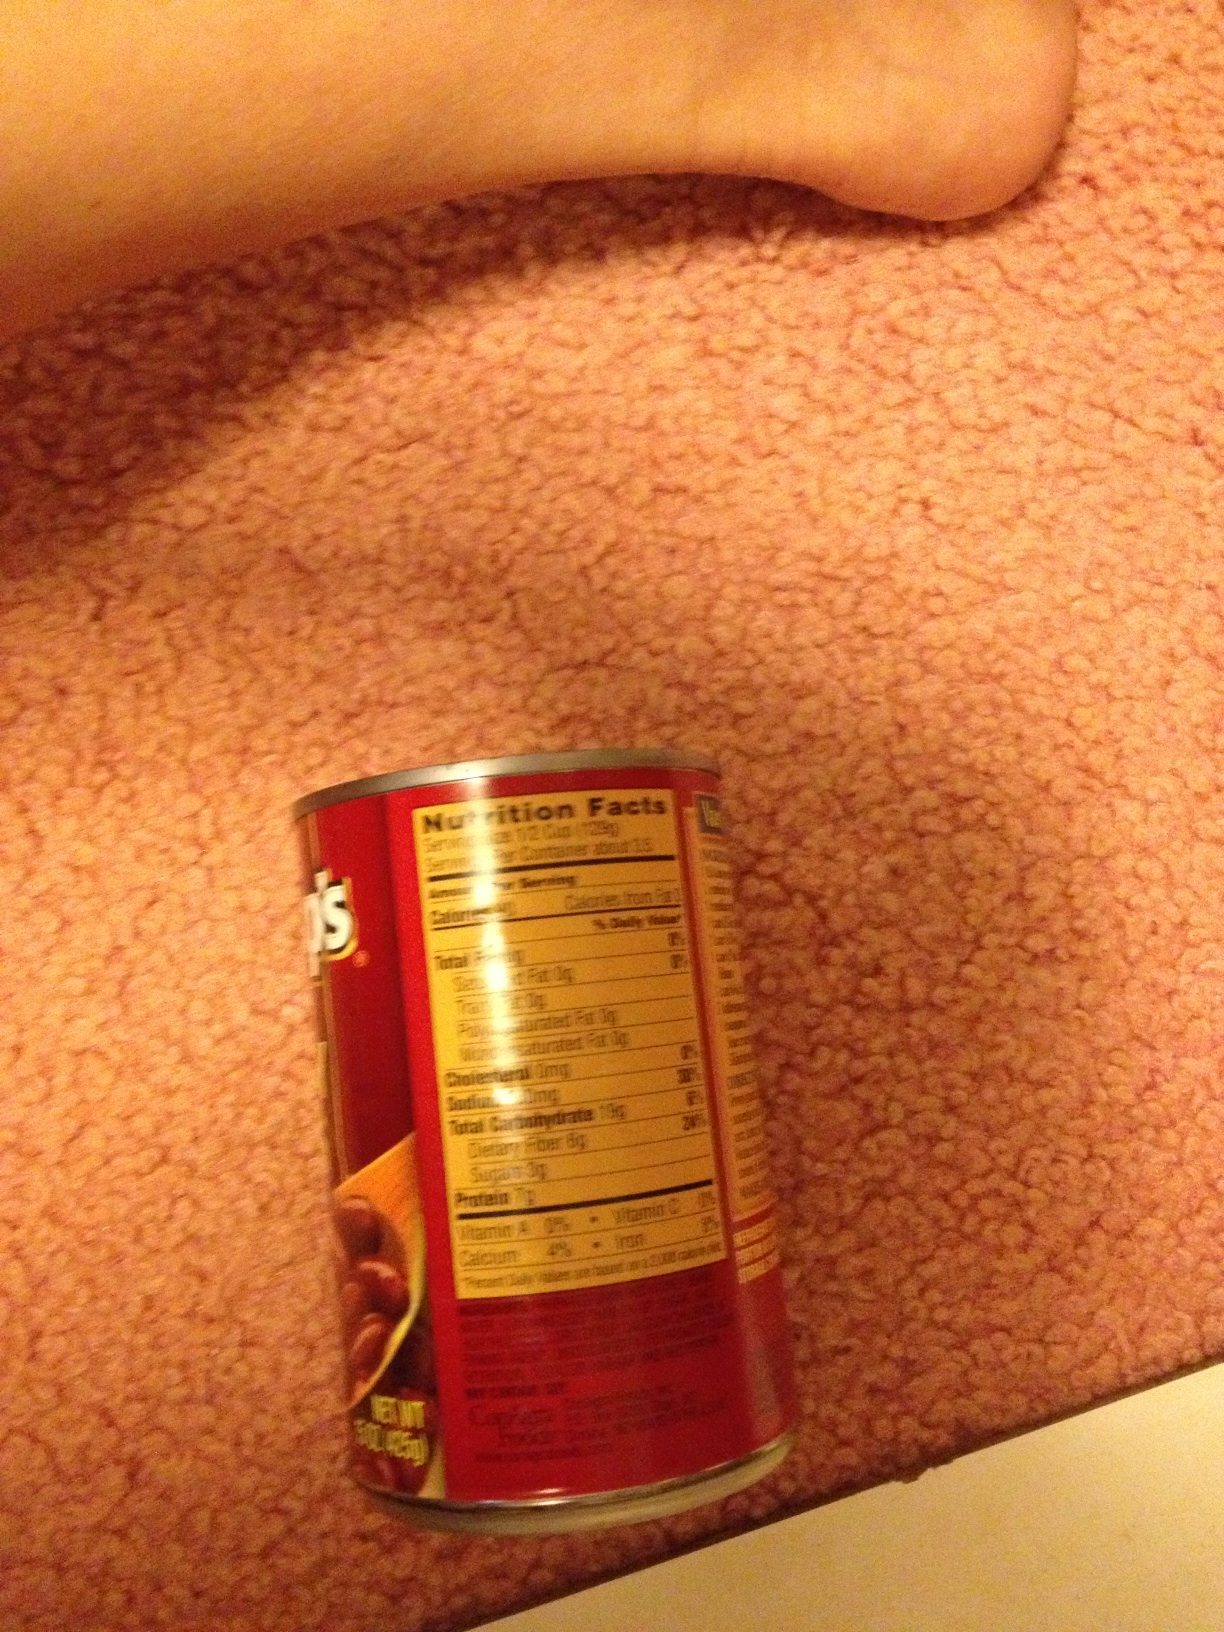Imagine this can is a time traveler. Where has it been, and what has it seen? This can of beans, a seasoned time traveler, has witnessed eras of culinary history. It journeyed through the ancient kitchens of Rome, where beans were a staple protein source. It traveled to medieval Europe, seeing how beans were cultivated and consumed by villagers. In the 1800s, it was introduced to the Americas, adapting to various recipes from Latin America to the Deep South. It even experienced the rationing era of World War II, where canned goods were essential. Throughout its travels, it has seen beans evolve from a humble crop to a versatile ingredient in various cuisines. What realistic scenario would involve this can of beans in someone's everyday life? A busy parent is preparing a quick and healthy dinner for their family. They open the pantry and grab this can of beans. Within minutes, they add it to a vegetable stir-fry for a nutritious and satisfying meal. Describe another realistic scenario, but this time it's a short one. In a rush to make a late-night snack, a college student opens this can of beans to make a quick and delicious bean dip. 